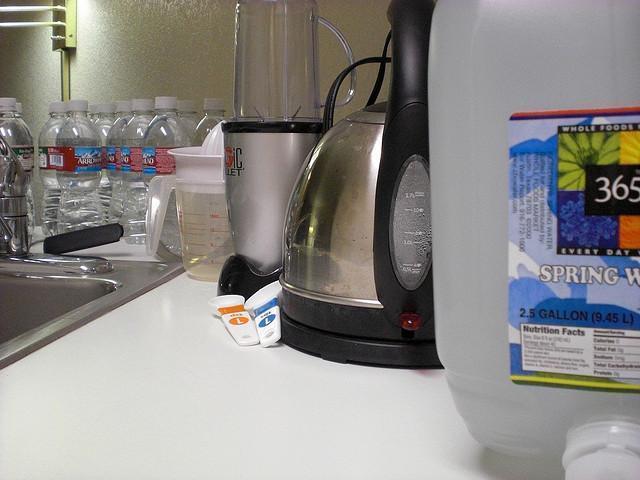How many bottles are visible?
Give a very brief answer. 4. 